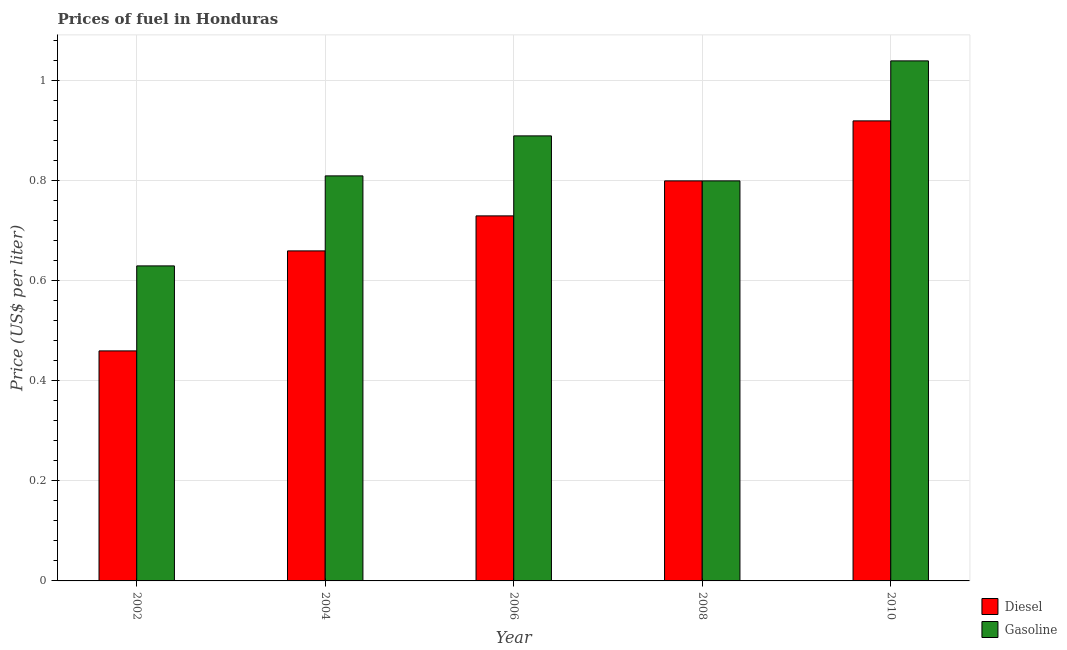How many groups of bars are there?
Your answer should be very brief. 5. Are the number of bars on each tick of the X-axis equal?
Make the answer very short. Yes. What is the diesel price in 2010?
Provide a succinct answer. 0.92. Across all years, what is the minimum diesel price?
Ensure brevity in your answer.  0.46. In which year was the diesel price maximum?
Your answer should be very brief. 2010. In which year was the diesel price minimum?
Make the answer very short. 2002. What is the total gasoline price in the graph?
Provide a succinct answer. 4.17. What is the difference between the gasoline price in 2002 and that in 2006?
Your answer should be compact. -0.26. What is the difference between the gasoline price in 2010 and the diesel price in 2002?
Provide a succinct answer. 0.41. What is the average diesel price per year?
Offer a very short reply. 0.71. In how many years, is the diesel price greater than 0.88 US$ per litre?
Keep it short and to the point. 1. What is the ratio of the diesel price in 2002 to that in 2008?
Make the answer very short. 0.57. Is the diesel price in 2004 less than that in 2010?
Your response must be concise. Yes. What is the difference between the highest and the second highest gasoline price?
Make the answer very short. 0.15. What is the difference between the highest and the lowest gasoline price?
Your answer should be very brief. 0.41. Is the sum of the gasoline price in 2002 and 2006 greater than the maximum diesel price across all years?
Your response must be concise. Yes. What does the 1st bar from the left in 2002 represents?
Offer a terse response. Diesel. What does the 2nd bar from the right in 2010 represents?
Ensure brevity in your answer.  Diesel. How many bars are there?
Offer a very short reply. 10. Are all the bars in the graph horizontal?
Offer a terse response. No. Where does the legend appear in the graph?
Give a very brief answer. Bottom right. How are the legend labels stacked?
Offer a terse response. Vertical. What is the title of the graph?
Your answer should be very brief. Prices of fuel in Honduras. What is the label or title of the Y-axis?
Your answer should be compact. Price (US$ per liter). What is the Price (US$ per liter) of Diesel in 2002?
Make the answer very short. 0.46. What is the Price (US$ per liter) of Gasoline in 2002?
Provide a short and direct response. 0.63. What is the Price (US$ per liter) of Diesel in 2004?
Your answer should be compact. 0.66. What is the Price (US$ per liter) of Gasoline in 2004?
Offer a very short reply. 0.81. What is the Price (US$ per liter) in Diesel in 2006?
Ensure brevity in your answer.  0.73. What is the Price (US$ per liter) of Gasoline in 2006?
Keep it short and to the point. 0.89. What is the Price (US$ per liter) in Gasoline in 2008?
Keep it short and to the point. 0.8. What is the Price (US$ per liter) of Diesel in 2010?
Your answer should be compact. 0.92. What is the Price (US$ per liter) in Gasoline in 2010?
Your response must be concise. 1.04. Across all years, what is the minimum Price (US$ per liter) in Diesel?
Offer a very short reply. 0.46. Across all years, what is the minimum Price (US$ per liter) in Gasoline?
Your response must be concise. 0.63. What is the total Price (US$ per liter) of Diesel in the graph?
Provide a succinct answer. 3.57. What is the total Price (US$ per liter) in Gasoline in the graph?
Ensure brevity in your answer.  4.17. What is the difference between the Price (US$ per liter) of Gasoline in 2002 and that in 2004?
Make the answer very short. -0.18. What is the difference between the Price (US$ per liter) of Diesel in 2002 and that in 2006?
Provide a succinct answer. -0.27. What is the difference between the Price (US$ per liter) in Gasoline in 2002 and that in 2006?
Offer a terse response. -0.26. What is the difference between the Price (US$ per liter) in Diesel in 2002 and that in 2008?
Your answer should be very brief. -0.34. What is the difference between the Price (US$ per liter) of Gasoline in 2002 and that in 2008?
Your answer should be very brief. -0.17. What is the difference between the Price (US$ per liter) in Diesel in 2002 and that in 2010?
Offer a very short reply. -0.46. What is the difference between the Price (US$ per liter) of Gasoline in 2002 and that in 2010?
Your answer should be compact. -0.41. What is the difference between the Price (US$ per liter) of Diesel in 2004 and that in 2006?
Offer a terse response. -0.07. What is the difference between the Price (US$ per liter) of Gasoline in 2004 and that in 2006?
Offer a very short reply. -0.08. What is the difference between the Price (US$ per liter) of Diesel in 2004 and that in 2008?
Your response must be concise. -0.14. What is the difference between the Price (US$ per liter) of Diesel in 2004 and that in 2010?
Offer a very short reply. -0.26. What is the difference between the Price (US$ per liter) in Gasoline in 2004 and that in 2010?
Provide a short and direct response. -0.23. What is the difference between the Price (US$ per liter) in Diesel in 2006 and that in 2008?
Offer a terse response. -0.07. What is the difference between the Price (US$ per liter) in Gasoline in 2006 and that in 2008?
Keep it short and to the point. 0.09. What is the difference between the Price (US$ per liter) in Diesel in 2006 and that in 2010?
Provide a succinct answer. -0.19. What is the difference between the Price (US$ per liter) of Gasoline in 2006 and that in 2010?
Offer a very short reply. -0.15. What is the difference between the Price (US$ per liter) of Diesel in 2008 and that in 2010?
Offer a terse response. -0.12. What is the difference between the Price (US$ per liter) in Gasoline in 2008 and that in 2010?
Your answer should be very brief. -0.24. What is the difference between the Price (US$ per liter) of Diesel in 2002 and the Price (US$ per liter) of Gasoline in 2004?
Make the answer very short. -0.35. What is the difference between the Price (US$ per liter) of Diesel in 2002 and the Price (US$ per liter) of Gasoline in 2006?
Your answer should be very brief. -0.43. What is the difference between the Price (US$ per liter) in Diesel in 2002 and the Price (US$ per liter) in Gasoline in 2008?
Provide a succinct answer. -0.34. What is the difference between the Price (US$ per liter) of Diesel in 2002 and the Price (US$ per liter) of Gasoline in 2010?
Keep it short and to the point. -0.58. What is the difference between the Price (US$ per liter) of Diesel in 2004 and the Price (US$ per liter) of Gasoline in 2006?
Keep it short and to the point. -0.23. What is the difference between the Price (US$ per liter) in Diesel in 2004 and the Price (US$ per liter) in Gasoline in 2008?
Make the answer very short. -0.14. What is the difference between the Price (US$ per liter) of Diesel in 2004 and the Price (US$ per liter) of Gasoline in 2010?
Offer a terse response. -0.38. What is the difference between the Price (US$ per liter) in Diesel in 2006 and the Price (US$ per liter) in Gasoline in 2008?
Offer a very short reply. -0.07. What is the difference between the Price (US$ per liter) of Diesel in 2006 and the Price (US$ per liter) of Gasoline in 2010?
Provide a succinct answer. -0.31. What is the difference between the Price (US$ per liter) of Diesel in 2008 and the Price (US$ per liter) of Gasoline in 2010?
Offer a terse response. -0.24. What is the average Price (US$ per liter) of Diesel per year?
Ensure brevity in your answer.  0.71. What is the average Price (US$ per liter) in Gasoline per year?
Give a very brief answer. 0.83. In the year 2002, what is the difference between the Price (US$ per liter) of Diesel and Price (US$ per liter) of Gasoline?
Your answer should be compact. -0.17. In the year 2004, what is the difference between the Price (US$ per liter) in Diesel and Price (US$ per liter) in Gasoline?
Ensure brevity in your answer.  -0.15. In the year 2006, what is the difference between the Price (US$ per liter) in Diesel and Price (US$ per liter) in Gasoline?
Provide a succinct answer. -0.16. In the year 2008, what is the difference between the Price (US$ per liter) in Diesel and Price (US$ per liter) in Gasoline?
Offer a very short reply. 0. In the year 2010, what is the difference between the Price (US$ per liter) of Diesel and Price (US$ per liter) of Gasoline?
Provide a succinct answer. -0.12. What is the ratio of the Price (US$ per liter) in Diesel in 2002 to that in 2004?
Your answer should be compact. 0.7. What is the ratio of the Price (US$ per liter) in Gasoline in 2002 to that in 2004?
Offer a terse response. 0.78. What is the ratio of the Price (US$ per liter) in Diesel in 2002 to that in 2006?
Provide a short and direct response. 0.63. What is the ratio of the Price (US$ per liter) of Gasoline in 2002 to that in 2006?
Your answer should be very brief. 0.71. What is the ratio of the Price (US$ per liter) of Diesel in 2002 to that in 2008?
Your answer should be very brief. 0.57. What is the ratio of the Price (US$ per liter) of Gasoline in 2002 to that in 2008?
Your answer should be compact. 0.79. What is the ratio of the Price (US$ per liter) of Diesel in 2002 to that in 2010?
Your answer should be compact. 0.5. What is the ratio of the Price (US$ per liter) in Gasoline in 2002 to that in 2010?
Provide a short and direct response. 0.61. What is the ratio of the Price (US$ per liter) of Diesel in 2004 to that in 2006?
Offer a very short reply. 0.9. What is the ratio of the Price (US$ per liter) of Gasoline in 2004 to that in 2006?
Ensure brevity in your answer.  0.91. What is the ratio of the Price (US$ per liter) in Diesel in 2004 to that in 2008?
Your answer should be very brief. 0.82. What is the ratio of the Price (US$ per liter) in Gasoline in 2004 to that in 2008?
Offer a terse response. 1.01. What is the ratio of the Price (US$ per liter) of Diesel in 2004 to that in 2010?
Ensure brevity in your answer.  0.72. What is the ratio of the Price (US$ per liter) of Gasoline in 2004 to that in 2010?
Offer a very short reply. 0.78. What is the ratio of the Price (US$ per liter) in Diesel in 2006 to that in 2008?
Make the answer very short. 0.91. What is the ratio of the Price (US$ per liter) in Gasoline in 2006 to that in 2008?
Your answer should be compact. 1.11. What is the ratio of the Price (US$ per liter) of Diesel in 2006 to that in 2010?
Make the answer very short. 0.79. What is the ratio of the Price (US$ per liter) in Gasoline in 2006 to that in 2010?
Make the answer very short. 0.86. What is the ratio of the Price (US$ per liter) of Diesel in 2008 to that in 2010?
Ensure brevity in your answer.  0.87. What is the ratio of the Price (US$ per liter) of Gasoline in 2008 to that in 2010?
Your answer should be very brief. 0.77. What is the difference between the highest and the second highest Price (US$ per liter) in Diesel?
Give a very brief answer. 0.12. What is the difference between the highest and the lowest Price (US$ per liter) in Diesel?
Your response must be concise. 0.46. What is the difference between the highest and the lowest Price (US$ per liter) in Gasoline?
Your answer should be compact. 0.41. 